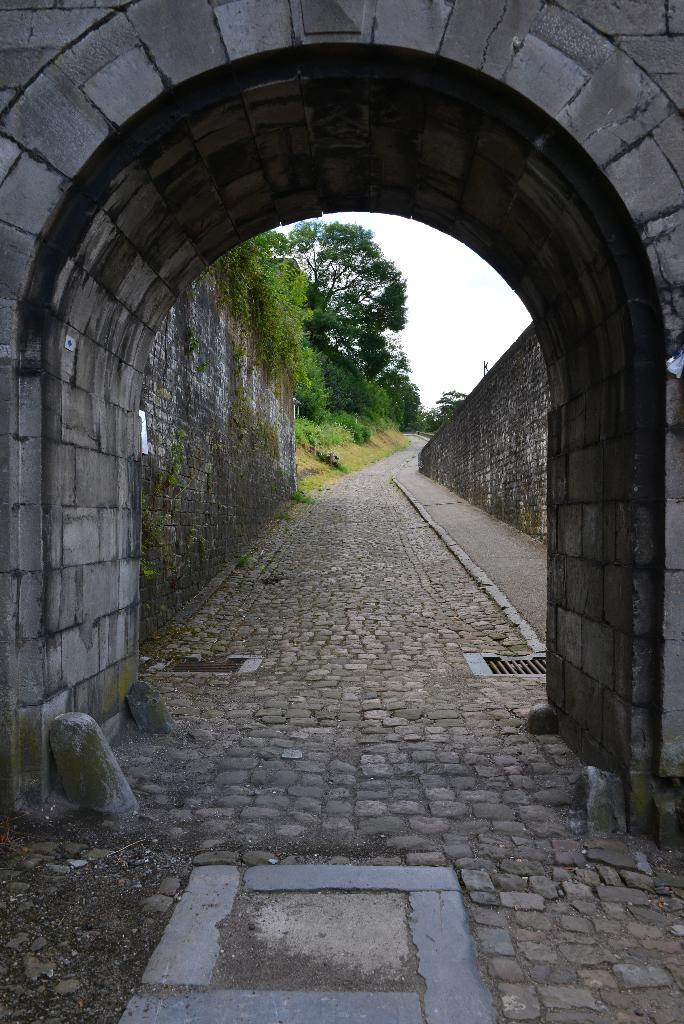What type of structure is present in the image? There is a granite arch in the image. What material is used for the walking area? The walking area is made of cobbler stones. What can be seen in the background of the image? There is a big granite wall and trees in the background. Where is the hill located in the image? There is no hill present in the image. What type of hair can be seen on the granite wall in the image? There is no hair present in the image, as it features a granite wall and other inanimate objects. 